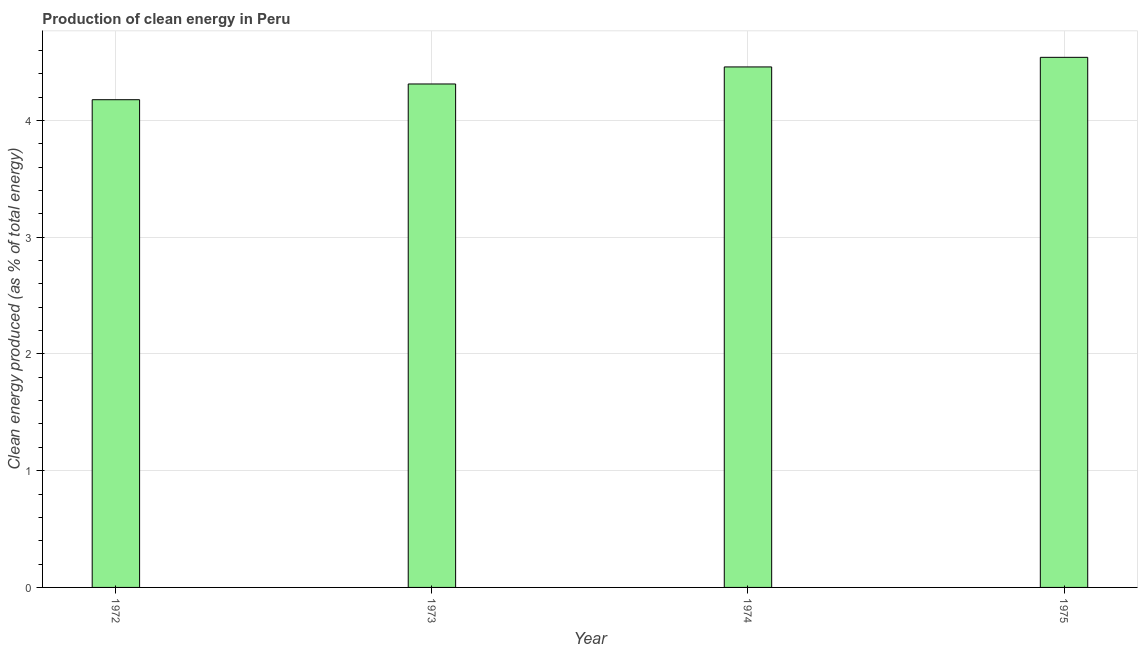What is the title of the graph?
Your answer should be compact. Production of clean energy in Peru. What is the label or title of the X-axis?
Keep it short and to the point. Year. What is the label or title of the Y-axis?
Offer a very short reply. Clean energy produced (as % of total energy). What is the production of clean energy in 1972?
Keep it short and to the point. 4.18. Across all years, what is the maximum production of clean energy?
Your response must be concise. 4.54. Across all years, what is the minimum production of clean energy?
Keep it short and to the point. 4.18. In which year was the production of clean energy maximum?
Make the answer very short. 1975. In which year was the production of clean energy minimum?
Provide a short and direct response. 1972. What is the sum of the production of clean energy?
Ensure brevity in your answer.  17.49. What is the difference between the production of clean energy in 1972 and 1974?
Your answer should be compact. -0.28. What is the average production of clean energy per year?
Your answer should be very brief. 4.37. What is the median production of clean energy?
Make the answer very short. 4.39. In how many years, is the production of clean energy greater than 4.4 %?
Offer a terse response. 2. Do a majority of the years between 1973 and 1972 (inclusive) have production of clean energy greater than 2 %?
Give a very brief answer. No. What is the ratio of the production of clean energy in 1973 to that in 1974?
Your answer should be compact. 0.97. Is the production of clean energy in 1972 less than that in 1974?
Ensure brevity in your answer.  Yes. Is the difference between the production of clean energy in 1972 and 1975 greater than the difference between any two years?
Your answer should be compact. Yes. What is the difference between the highest and the second highest production of clean energy?
Offer a very short reply. 0.08. Is the sum of the production of clean energy in 1972 and 1975 greater than the maximum production of clean energy across all years?
Offer a terse response. Yes. What is the difference between the highest and the lowest production of clean energy?
Make the answer very short. 0.36. Are all the bars in the graph horizontal?
Make the answer very short. No. What is the Clean energy produced (as % of total energy) in 1972?
Your answer should be very brief. 4.18. What is the Clean energy produced (as % of total energy) of 1973?
Keep it short and to the point. 4.31. What is the Clean energy produced (as % of total energy) in 1974?
Provide a short and direct response. 4.46. What is the Clean energy produced (as % of total energy) in 1975?
Your answer should be compact. 4.54. What is the difference between the Clean energy produced (as % of total energy) in 1972 and 1973?
Ensure brevity in your answer.  -0.13. What is the difference between the Clean energy produced (as % of total energy) in 1972 and 1974?
Your answer should be compact. -0.28. What is the difference between the Clean energy produced (as % of total energy) in 1972 and 1975?
Ensure brevity in your answer.  -0.36. What is the difference between the Clean energy produced (as % of total energy) in 1973 and 1974?
Your answer should be very brief. -0.15. What is the difference between the Clean energy produced (as % of total energy) in 1973 and 1975?
Offer a terse response. -0.23. What is the difference between the Clean energy produced (as % of total energy) in 1974 and 1975?
Give a very brief answer. -0.08. What is the ratio of the Clean energy produced (as % of total energy) in 1972 to that in 1974?
Provide a short and direct response. 0.94. What is the ratio of the Clean energy produced (as % of total energy) in 1974 to that in 1975?
Your response must be concise. 0.98. 